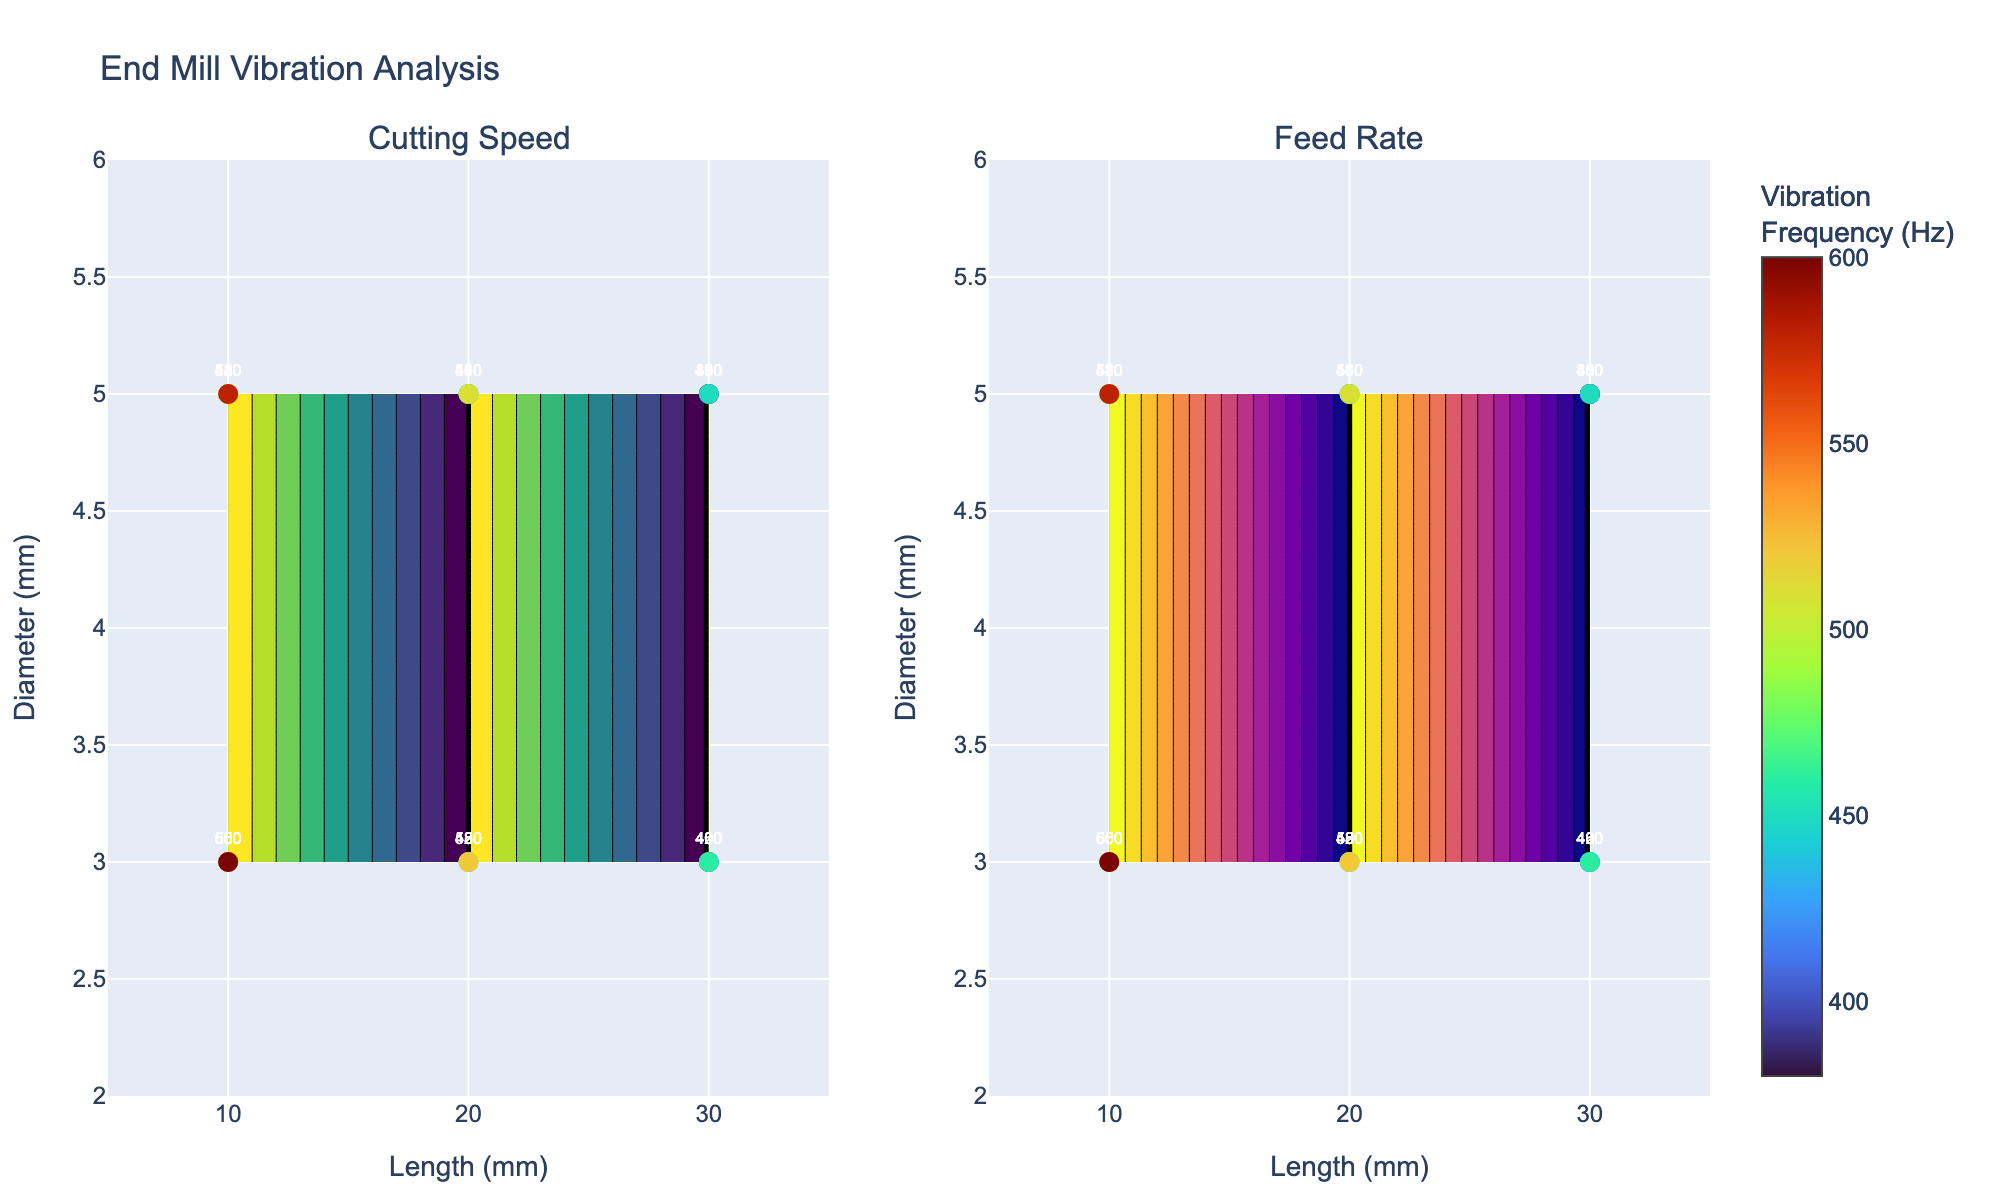What's the title of the plot? The title is usually located at the upper center of the figure. In this case, it reads "End Mill Vibration Analysis".
Answer: End Mill Vibration Analysis What are the x-axis and y-axis labels? The axis labels are typically shown along the respective axes. The x-axis is labeled "Length (mm)" and the y-axis is labeled "Diameter (mm)".
Answer: Length (mm), Diameter (mm) Describe the color scales used in the contour plots. The color scales indicate the intensity values of the data being plotted. The first contour plot uses a "Viridis" color scale, and the second contour plot uses a "Plasma" color scale.
Answer: Viridis, Plasma What is the range of the x-axis? The x-axis range is given from 5 to 35, as indicated near the x-axis at the bottom of the figure.
Answer: 5 to 35 What does the color of the scatter plot markers indicate? The color of the scatter plot markers represents the Vibration Frequency in Hz, as shown in the color bar at the right side of the figures.
Answer: Vibration Frequency (Hz) Which contour plot appears on the left side, and what variable does it represent? From the subplot titles, we can see that the contour plot on the left represents "Cutting Speed".
Answer: Cutting Speed Compare the vibration frequencies for end mills of lengths 10 mm and 20 mm with a 5 mm diameter at a feed rate of 0.08 mm/tooth. Observing the scatter plot, the vibration frequencies for these conditions are given as 480 Hz for 10 mm length and 430 Hz for 20 mm length.
Answer: 480 Hz, 430 Hz What's the general trend in vibration frequency as the length of the end mills increases for a 3 mm diameter? By examining the scatter plot markers labeled with vibration frequencies, we can see that for a fixed diameter of 3 mm, the vibration frequency decreases as the length increases.
Answer: Decreases How does the vibration frequency correlate with the cutting speed based on the figure? Generally, as seen in the left contour plot and labeled frequencies, the vibration frequency tends to increase with higher cutting speeds. For example, vibration frequency increases from 500 Hz to 600 Hz as the cutting speed increases from 100 m/min to 300 m/min for the 10 mm length and 3 mm diameter.
Answer: Increases Which end mill condition has the lowest vibration frequency, and what are its length, diameter, and cutting speed? Checking the marker with the lowest vibration frequency, 380 Hz, it corresponds to an end mill with a length of 30 mm, a diameter of 5 mm, and a cutting speed of 100 m/min.
Answer: 30 mm, 5 mm, 100 m/min 